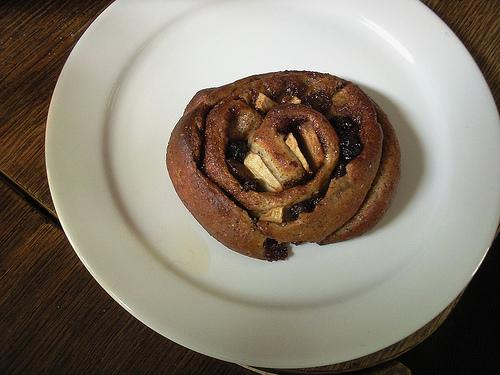Narrate the picture as if describing it to someone who can't see it. Imagine a round, swirly cinnamon roll with raisins and apple chunks nestled in its layers, sitting on a white, plain plate on a wooden table. Explain the setting where the main subject is placed. The cinnamon roll is placed on a white round plate that is located on a section of a brown wooden table. Write a one-sentence description capturing the main elements of the image. A scrumptious cinnamon roll with raisins and apple bits lies on a spotless white plate atop a dark wooden table. Provide a simple and concise description of the image. A delicious cinnamon roll is served on a white plate resting on a wooden table. Write a short sentence about the scene's overall atmosphere. It's a cozy scene with a yummy-looking cinnamon roll on a clean white plate, set on a rustic wooden table. Mention the types of food on the plate. There's a cinnamon roll with raisins, apple chunks, and gooey filling on a plate. Give a brief description of the main object and its surroundings. A cinnamon roll with raisins and apple chunks is on a white plate, placed on a brown wooden table. Describe the image focusing on the textures present. A yummy-looking cinnamon roll with many swirls sits on a clean, white plate on a brown wooden table with a seam and light reflections. Describe in detail the appearance of the main subject. The cinnamon roll appears brown and has many swirls, with raisins and apple chunks in between the layers, as well as gooey filling. Mention the key elements of the scene and their colors. There's a brown cinnamon roll with raisins, apple chunks, and gooey filling on a white round plate, atop a dark brown wooden table. 